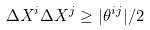<formula> <loc_0><loc_0><loc_500><loc_500>\Delta X ^ { i } \Delta X ^ { j } \geq | \theta ^ { i j } | / 2</formula> 